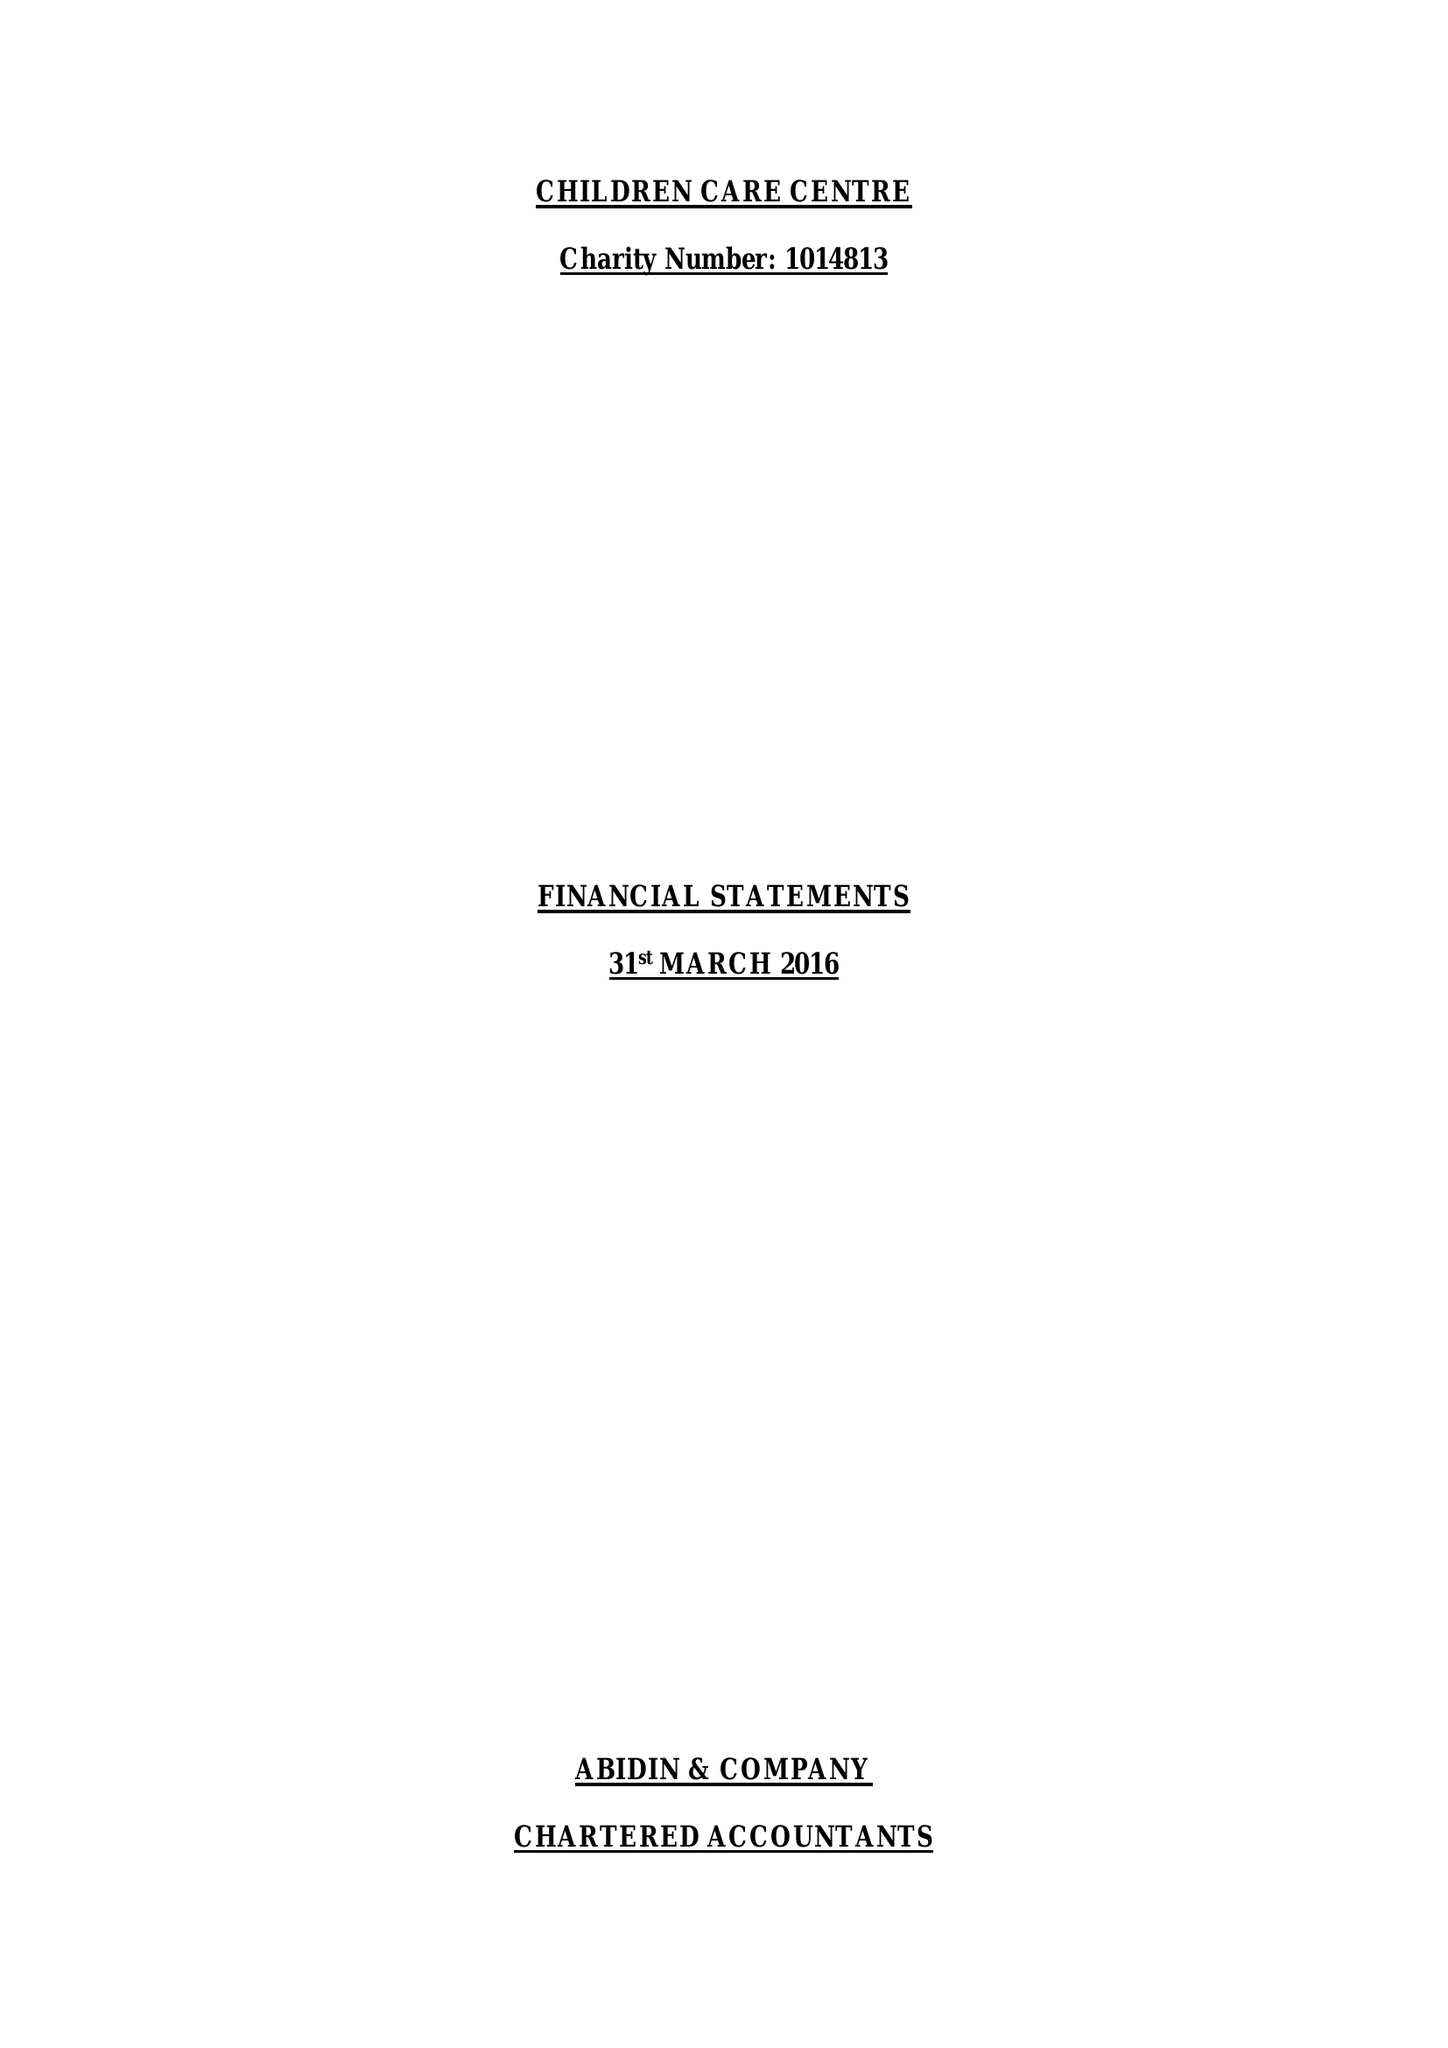What is the value for the address__post_town?
Answer the question using a single word or phrase. LONDON 